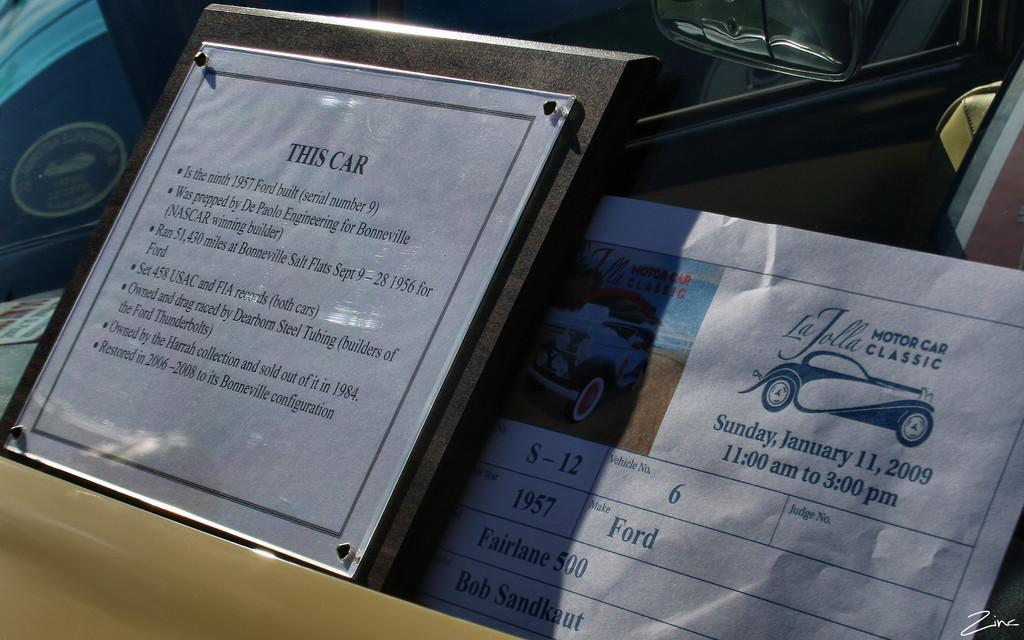What is the main object in the image? There is a board in the image. What other furniture or objects can be seen in the image? There is a table in the image. Is there any source of natural light in the image? Yes, there is a window in the image. Where might this image have been taken? The image is likely taken in a room, given the presence of a table and a window. What type of quince is being used to sew a glove in the image? There is no quince, glove, or sewing activity present in the image. 